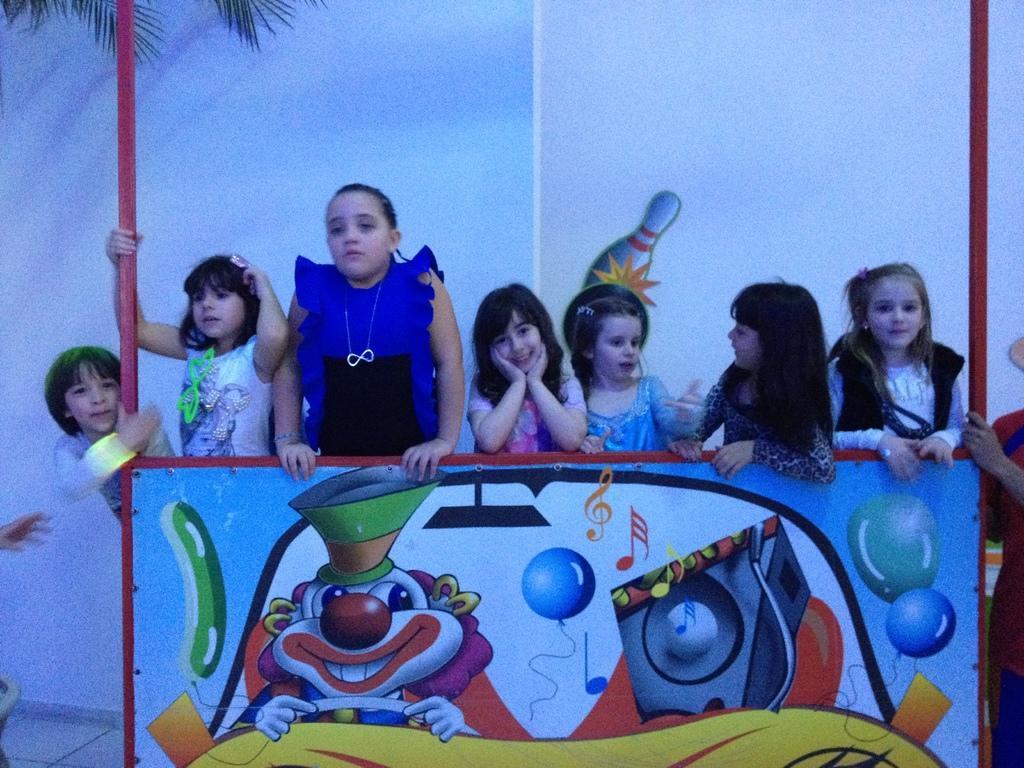Could you give a brief overview of what you see in this image? This picture is clicked outside. In the foreground we can see the picture of a clown riding a vehicle and we can see the pictures of balloons on a red color object and we can see the group of children seems to be standing. In the background there is a wall on which we can see some pictures and the leaves of a tree. 